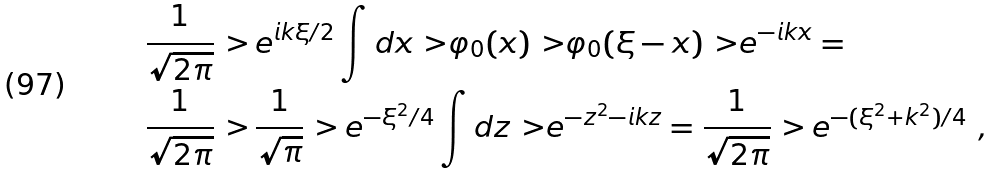<formula> <loc_0><loc_0><loc_500><loc_500>& \frac { 1 } { \sqrt { 2 \pi } } { \ > \, } e ^ { i k \xi / 2 } \int d x { \ > } \varphi _ { 0 } ( x ) { \ > } \varphi _ { 0 } ( \xi - x ) { \ > } e ^ { - i k x } = \\ & \frac { 1 } { \sqrt { 2 \pi } } { \ > \, } \frac { 1 } { \sqrt { \pi } } { \ > \, } e ^ { - \xi ^ { 2 } / 4 } \int d z { \ > } e ^ { - z ^ { 2 } - i k z } = \frac { 1 } { \sqrt { 2 \pi } } { \ > \, } e ^ { - ( \xi ^ { 2 } + k ^ { 2 } ) / 4 } \ ,</formula> 